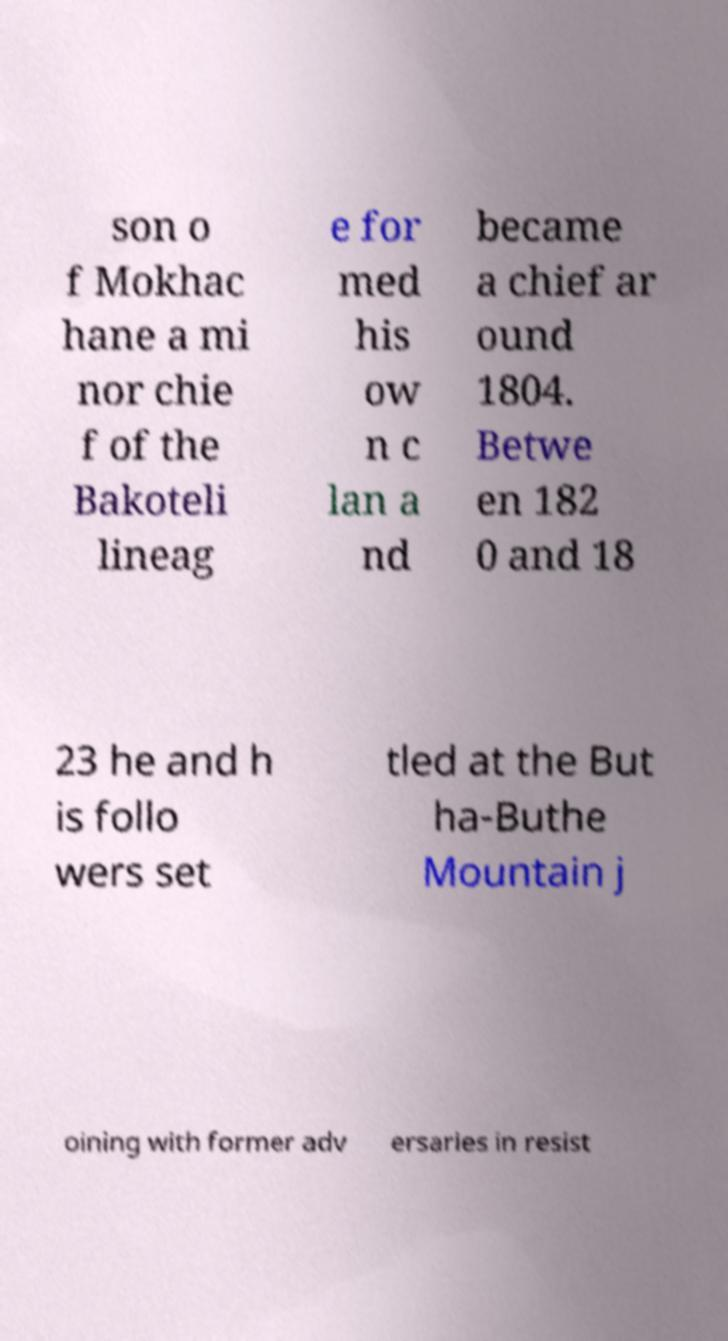Please read and relay the text visible in this image. What does it say? son o f Mokhac hane a mi nor chie f of the Bakoteli lineag e for med his ow n c lan a nd became a chief ar ound 1804. Betwe en 182 0 and 18 23 he and h is follo wers set tled at the But ha-Buthe Mountain j oining with former adv ersaries in resist 